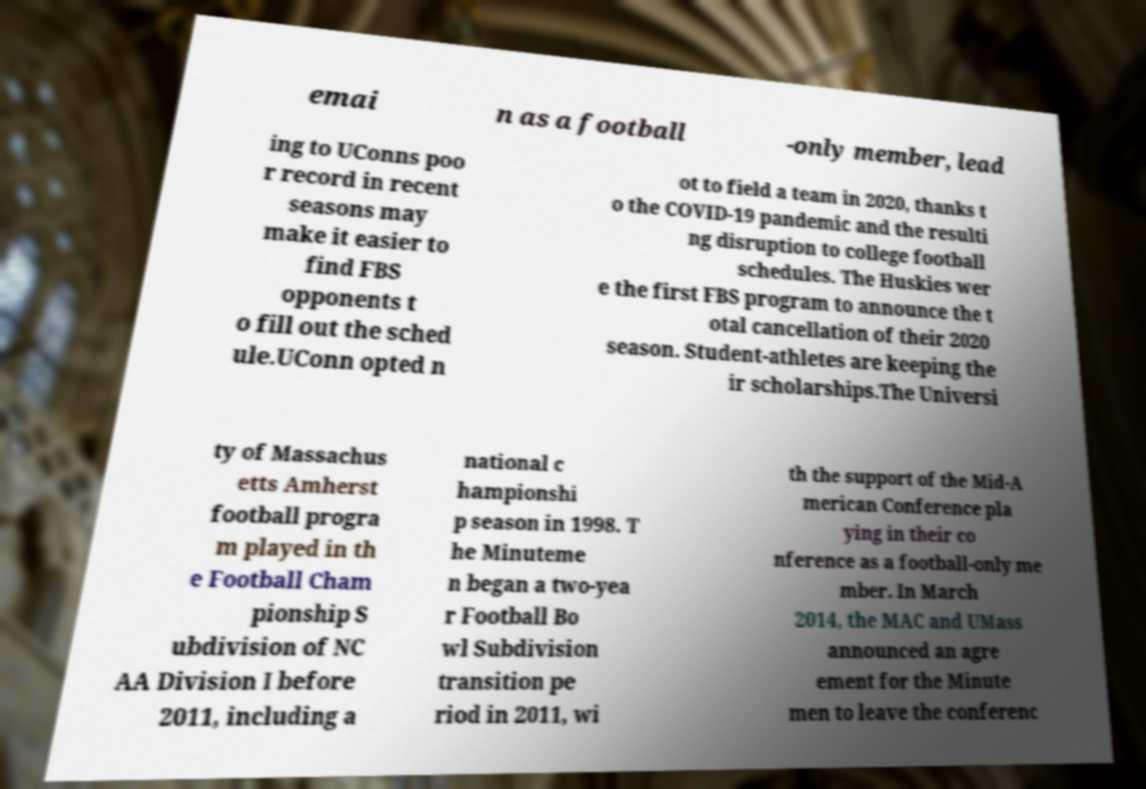Could you extract and type out the text from this image? emai n as a football -only member, lead ing to UConns poo r record in recent seasons may make it easier to find FBS opponents t o fill out the sched ule.UConn opted n ot to field a team in 2020, thanks t o the COVID-19 pandemic and the resulti ng disruption to college football schedules. The Huskies wer e the first FBS program to announce the t otal cancellation of their 2020 season. Student-athletes are keeping the ir scholarships.The Universi ty of Massachus etts Amherst football progra m played in th e Football Cham pionship S ubdivision of NC AA Division I before 2011, including a national c hampionshi p season in 1998. T he Minuteme n began a two-yea r Football Bo wl Subdivision transition pe riod in 2011, wi th the support of the Mid-A merican Conference pla ying in their co nference as a football-only me mber. In March 2014, the MAC and UMass announced an agre ement for the Minute men to leave the conferenc 